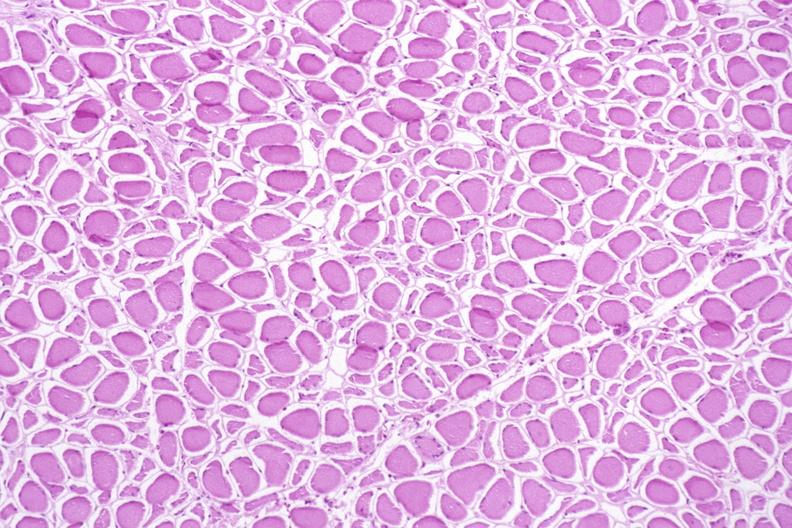does this image show skeletal muscle, atrophy due to immobilization cast?
Answer the question using a single word or phrase. Yes 